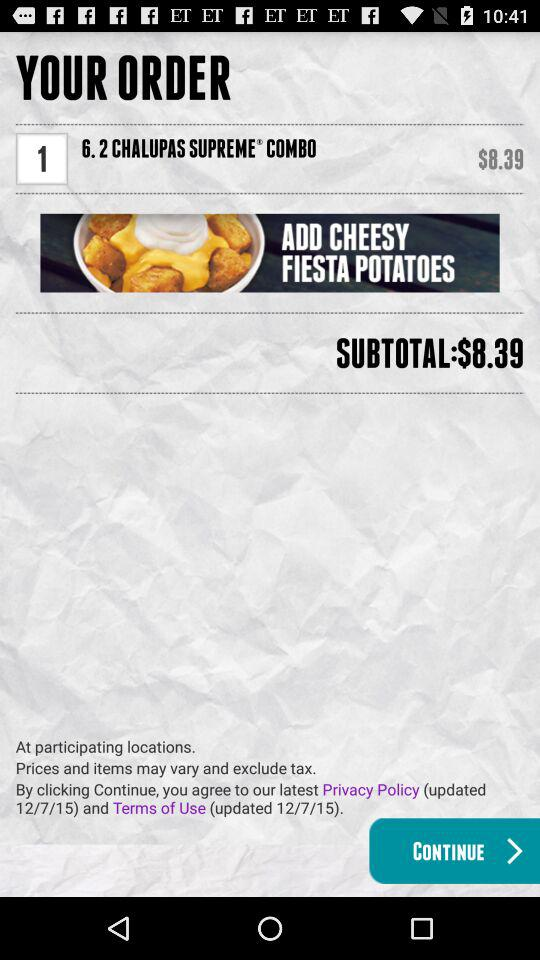How many items are in the order?
Answer the question using a single word or phrase. 1 